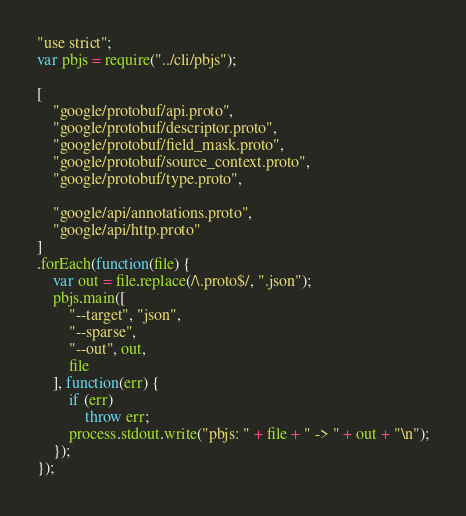<code> <loc_0><loc_0><loc_500><loc_500><_JavaScript_>"use strict";
var pbjs = require("../cli/pbjs");

[
    "google/protobuf/api.proto",
    "google/protobuf/descriptor.proto",
    "google/protobuf/field_mask.proto",
    "google/protobuf/source_context.proto",
    "google/protobuf/type.proto",

    "google/api/annotations.proto",
    "google/api/http.proto"
]
.forEach(function(file) {
    var out = file.replace(/\.proto$/, ".json");
    pbjs.main([
        "--target", "json",
        "--sparse",
        "--out", out,
        file
    ], function(err) {
        if (err)
            throw err;
        process.stdout.write("pbjs: " + file + " -> " + out + "\n");
    });
});</code> 